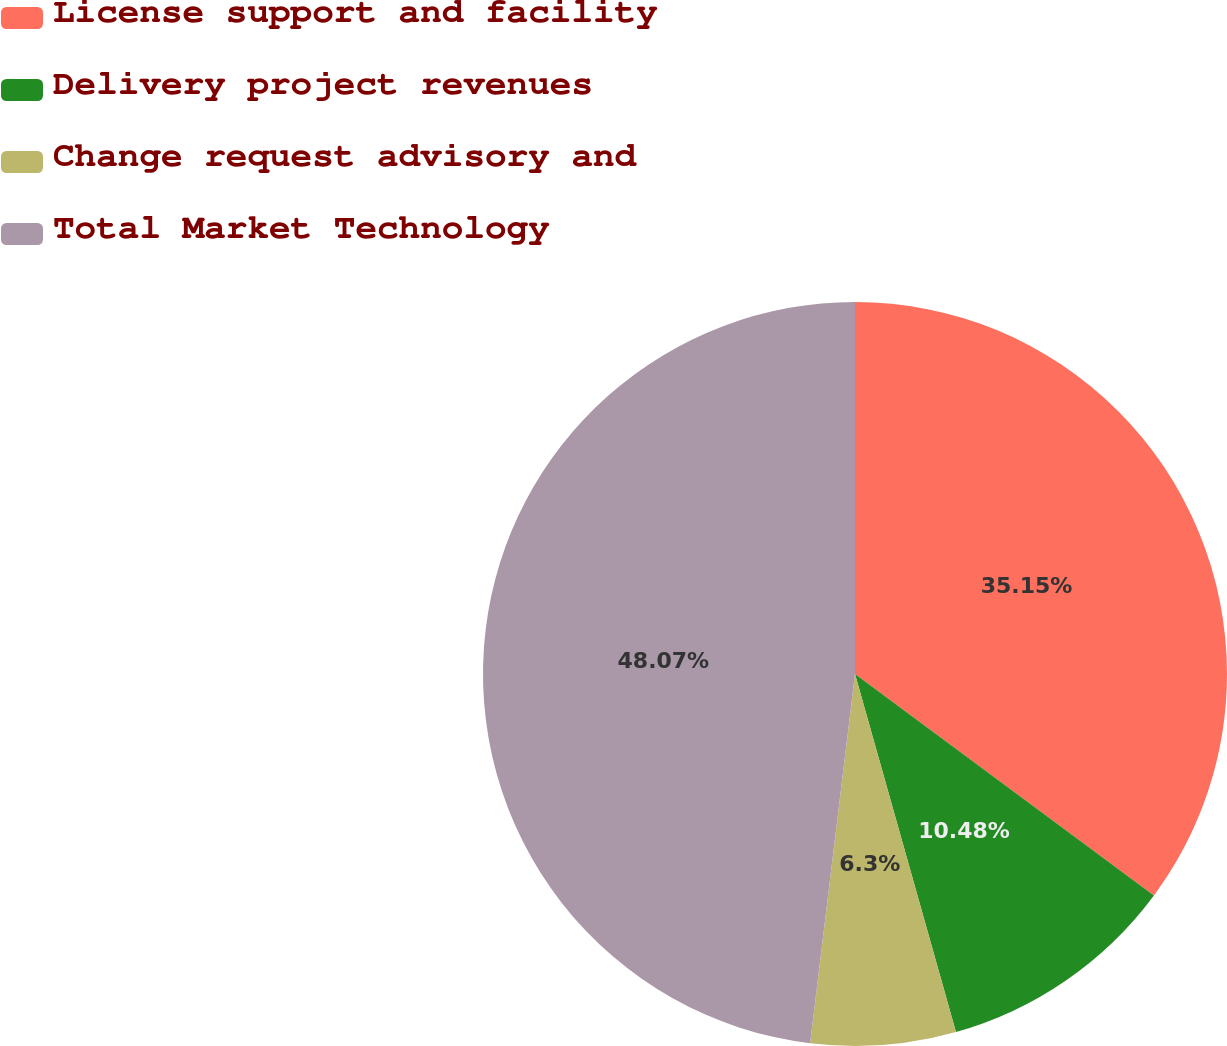Convert chart. <chart><loc_0><loc_0><loc_500><loc_500><pie_chart><fcel>License support and facility<fcel>Delivery project revenues<fcel>Change request advisory and<fcel>Total Market Technology<nl><fcel>35.15%<fcel>10.48%<fcel>6.3%<fcel>48.08%<nl></chart> 